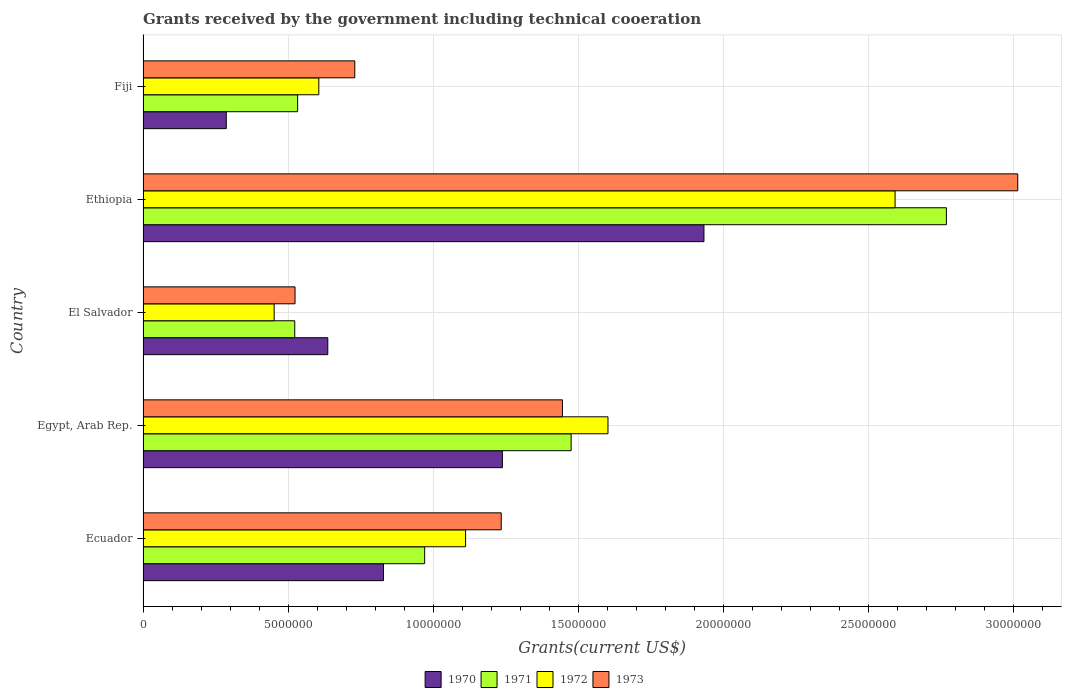How many different coloured bars are there?
Your answer should be compact. 4. Are the number of bars on each tick of the Y-axis equal?
Offer a terse response. Yes. How many bars are there on the 4th tick from the top?
Offer a very short reply. 4. How many bars are there on the 5th tick from the bottom?
Make the answer very short. 4. What is the label of the 3rd group of bars from the top?
Offer a very short reply. El Salvador. What is the total grants received by the government in 1973 in Ecuador?
Your answer should be compact. 1.24e+07. Across all countries, what is the maximum total grants received by the government in 1973?
Provide a short and direct response. 3.02e+07. Across all countries, what is the minimum total grants received by the government in 1970?
Provide a short and direct response. 2.87e+06. In which country was the total grants received by the government in 1972 maximum?
Your answer should be compact. Ethiopia. In which country was the total grants received by the government in 1973 minimum?
Offer a very short reply. El Salvador. What is the total total grants received by the government in 1971 in the graph?
Provide a short and direct response. 6.27e+07. What is the difference between the total grants received by the government in 1972 in Ecuador and that in Egypt, Arab Rep.?
Make the answer very short. -4.91e+06. What is the difference between the total grants received by the government in 1970 in Ecuador and the total grants received by the government in 1973 in El Salvador?
Your answer should be very brief. 3.05e+06. What is the average total grants received by the government in 1972 per country?
Provide a short and direct response. 1.27e+07. What is the difference between the total grants received by the government in 1971 and total grants received by the government in 1970 in Egypt, Arab Rep.?
Ensure brevity in your answer.  2.37e+06. In how many countries, is the total grants received by the government in 1973 greater than 5000000 US$?
Give a very brief answer. 5. What is the ratio of the total grants received by the government in 1971 in Egypt, Arab Rep. to that in Fiji?
Ensure brevity in your answer.  2.77. What is the difference between the highest and the second highest total grants received by the government in 1973?
Ensure brevity in your answer.  1.57e+07. What is the difference between the highest and the lowest total grants received by the government in 1970?
Provide a short and direct response. 1.65e+07. In how many countries, is the total grants received by the government in 1973 greater than the average total grants received by the government in 1973 taken over all countries?
Make the answer very short. 2. Is it the case that in every country, the sum of the total grants received by the government in 1972 and total grants received by the government in 1973 is greater than the sum of total grants received by the government in 1970 and total grants received by the government in 1971?
Make the answer very short. No. Is it the case that in every country, the sum of the total grants received by the government in 1970 and total grants received by the government in 1972 is greater than the total grants received by the government in 1971?
Offer a terse response. Yes. How many bars are there?
Offer a very short reply. 20. How many countries are there in the graph?
Your response must be concise. 5. What is the difference between two consecutive major ticks on the X-axis?
Keep it short and to the point. 5.00e+06. Where does the legend appear in the graph?
Offer a very short reply. Bottom center. How are the legend labels stacked?
Your answer should be compact. Horizontal. What is the title of the graph?
Give a very brief answer. Grants received by the government including technical cooeration. Does "2008" appear as one of the legend labels in the graph?
Offer a terse response. No. What is the label or title of the X-axis?
Ensure brevity in your answer.  Grants(current US$). What is the Grants(current US$) in 1970 in Ecuador?
Offer a terse response. 8.29e+06. What is the Grants(current US$) in 1971 in Ecuador?
Keep it short and to the point. 9.71e+06. What is the Grants(current US$) in 1972 in Ecuador?
Offer a very short reply. 1.11e+07. What is the Grants(current US$) in 1973 in Ecuador?
Make the answer very short. 1.24e+07. What is the Grants(current US$) in 1970 in Egypt, Arab Rep.?
Keep it short and to the point. 1.24e+07. What is the Grants(current US$) of 1971 in Egypt, Arab Rep.?
Ensure brevity in your answer.  1.48e+07. What is the Grants(current US$) in 1972 in Egypt, Arab Rep.?
Provide a succinct answer. 1.60e+07. What is the Grants(current US$) in 1973 in Egypt, Arab Rep.?
Your answer should be very brief. 1.45e+07. What is the Grants(current US$) in 1970 in El Salvador?
Your answer should be very brief. 6.37e+06. What is the Grants(current US$) of 1971 in El Salvador?
Keep it short and to the point. 5.23e+06. What is the Grants(current US$) in 1972 in El Salvador?
Ensure brevity in your answer.  4.52e+06. What is the Grants(current US$) of 1973 in El Salvador?
Offer a very short reply. 5.24e+06. What is the Grants(current US$) of 1970 in Ethiopia?
Your answer should be compact. 1.93e+07. What is the Grants(current US$) in 1971 in Ethiopia?
Provide a succinct answer. 2.77e+07. What is the Grants(current US$) in 1972 in Ethiopia?
Keep it short and to the point. 2.59e+07. What is the Grants(current US$) of 1973 in Ethiopia?
Ensure brevity in your answer.  3.02e+07. What is the Grants(current US$) in 1970 in Fiji?
Offer a very short reply. 2.87e+06. What is the Grants(current US$) of 1971 in Fiji?
Offer a terse response. 5.33e+06. What is the Grants(current US$) in 1972 in Fiji?
Your response must be concise. 6.06e+06. What is the Grants(current US$) of 1973 in Fiji?
Provide a succinct answer. 7.30e+06. Across all countries, what is the maximum Grants(current US$) of 1970?
Ensure brevity in your answer.  1.93e+07. Across all countries, what is the maximum Grants(current US$) of 1971?
Offer a very short reply. 2.77e+07. Across all countries, what is the maximum Grants(current US$) in 1972?
Ensure brevity in your answer.  2.59e+07. Across all countries, what is the maximum Grants(current US$) in 1973?
Offer a terse response. 3.02e+07. Across all countries, what is the minimum Grants(current US$) of 1970?
Your answer should be compact. 2.87e+06. Across all countries, what is the minimum Grants(current US$) in 1971?
Provide a succinct answer. 5.23e+06. Across all countries, what is the minimum Grants(current US$) of 1972?
Your response must be concise. 4.52e+06. Across all countries, what is the minimum Grants(current US$) in 1973?
Ensure brevity in your answer.  5.24e+06. What is the total Grants(current US$) in 1970 in the graph?
Keep it short and to the point. 4.93e+07. What is the total Grants(current US$) of 1971 in the graph?
Your answer should be compact. 6.27e+07. What is the total Grants(current US$) of 1972 in the graph?
Offer a terse response. 6.37e+07. What is the total Grants(current US$) of 1973 in the graph?
Your answer should be very brief. 6.95e+07. What is the difference between the Grants(current US$) of 1970 in Ecuador and that in Egypt, Arab Rep.?
Make the answer very short. -4.10e+06. What is the difference between the Grants(current US$) in 1971 in Ecuador and that in Egypt, Arab Rep.?
Offer a terse response. -5.05e+06. What is the difference between the Grants(current US$) in 1972 in Ecuador and that in Egypt, Arab Rep.?
Provide a short and direct response. -4.91e+06. What is the difference between the Grants(current US$) in 1973 in Ecuador and that in Egypt, Arab Rep.?
Give a very brief answer. -2.11e+06. What is the difference between the Grants(current US$) of 1970 in Ecuador and that in El Salvador?
Provide a succinct answer. 1.92e+06. What is the difference between the Grants(current US$) in 1971 in Ecuador and that in El Salvador?
Your response must be concise. 4.48e+06. What is the difference between the Grants(current US$) in 1972 in Ecuador and that in El Salvador?
Your response must be concise. 6.60e+06. What is the difference between the Grants(current US$) in 1973 in Ecuador and that in El Salvador?
Offer a terse response. 7.11e+06. What is the difference between the Grants(current US$) of 1970 in Ecuador and that in Ethiopia?
Your response must be concise. -1.10e+07. What is the difference between the Grants(current US$) of 1971 in Ecuador and that in Ethiopia?
Provide a short and direct response. -1.80e+07. What is the difference between the Grants(current US$) in 1972 in Ecuador and that in Ethiopia?
Your answer should be compact. -1.48e+07. What is the difference between the Grants(current US$) in 1973 in Ecuador and that in Ethiopia?
Provide a short and direct response. -1.78e+07. What is the difference between the Grants(current US$) in 1970 in Ecuador and that in Fiji?
Provide a succinct answer. 5.42e+06. What is the difference between the Grants(current US$) of 1971 in Ecuador and that in Fiji?
Your response must be concise. 4.38e+06. What is the difference between the Grants(current US$) of 1972 in Ecuador and that in Fiji?
Keep it short and to the point. 5.06e+06. What is the difference between the Grants(current US$) of 1973 in Ecuador and that in Fiji?
Make the answer very short. 5.05e+06. What is the difference between the Grants(current US$) of 1970 in Egypt, Arab Rep. and that in El Salvador?
Give a very brief answer. 6.02e+06. What is the difference between the Grants(current US$) in 1971 in Egypt, Arab Rep. and that in El Salvador?
Give a very brief answer. 9.53e+06. What is the difference between the Grants(current US$) in 1972 in Egypt, Arab Rep. and that in El Salvador?
Your answer should be very brief. 1.15e+07. What is the difference between the Grants(current US$) of 1973 in Egypt, Arab Rep. and that in El Salvador?
Your answer should be compact. 9.22e+06. What is the difference between the Grants(current US$) of 1970 in Egypt, Arab Rep. and that in Ethiopia?
Provide a succinct answer. -6.95e+06. What is the difference between the Grants(current US$) of 1971 in Egypt, Arab Rep. and that in Ethiopia?
Offer a very short reply. -1.29e+07. What is the difference between the Grants(current US$) of 1972 in Egypt, Arab Rep. and that in Ethiopia?
Make the answer very short. -9.90e+06. What is the difference between the Grants(current US$) in 1973 in Egypt, Arab Rep. and that in Ethiopia?
Your answer should be very brief. -1.57e+07. What is the difference between the Grants(current US$) in 1970 in Egypt, Arab Rep. and that in Fiji?
Keep it short and to the point. 9.52e+06. What is the difference between the Grants(current US$) of 1971 in Egypt, Arab Rep. and that in Fiji?
Make the answer very short. 9.43e+06. What is the difference between the Grants(current US$) of 1972 in Egypt, Arab Rep. and that in Fiji?
Your answer should be very brief. 9.97e+06. What is the difference between the Grants(current US$) of 1973 in Egypt, Arab Rep. and that in Fiji?
Your answer should be compact. 7.16e+06. What is the difference between the Grants(current US$) of 1970 in El Salvador and that in Ethiopia?
Make the answer very short. -1.30e+07. What is the difference between the Grants(current US$) in 1971 in El Salvador and that in Ethiopia?
Make the answer very short. -2.25e+07. What is the difference between the Grants(current US$) of 1972 in El Salvador and that in Ethiopia?
Give a very brief answer. -2.14e+07. What is the difference between the Grants(current US$) in 1973 in El Salvador and that in Ethiopia?
Ensure brevity in your answer.  -2.49e+07. What is the difference between the Grants(current US$) of 1970 in El Salvador and that in Fiji?
Offer a very short reply. 3.50e+06. What is the difference between the Grants(current US$) of 1972 in El Salvador and that in Fiji?
Make the answer very short. -1.54e+06. What is the difference between the Grants(current US$) in 1973 in El Salvador and that in Fiji?
Ensure brevity in your answer.  -2.06e+06. What is the difference between the Grants(current US$) in 1970 in Ethiopia and that in Fiji?
Offer a terse response. 1.65e+07. What is the difference between the Grants(current US$) of 1971 in Ethiopia and that in Fiji?
Your response must be concise. 2.24e+07. What is the difference between the Grants(current US$) of 1972 in Ethiopia and that in Fiji?
Your answer should be compact. 1.99e+07. What is the difference between the Grants(current US$) of 1973 in Ethiopia and that in Fiji?
Ensure brevity in your answer.  2.29e+07. What is the difference between the Grants(current US$) of 1970 in Ecuador and the Grants(current US$) of 1971 in Egypt, Arab Rep.?
Give a very brief answer. -6.47e+06. What is the difference between the Grants(current US$) in 1970 in Ecuador and the Grants(current US$) in 1972 in Egypt, Arab Rep.?
Ensure brevity in your answer.  -7.74e+06. What is the difference between the Grants(current US$) in 1970 in Ecuador and the Grants(current US$) in 1973 in Egypt, Arab Rep.?
Make the answer very short. -6.17e+06. What is the difference between the Grants(current US$) of 1971 in Ecuador and the Grants(current US$) of 1972 in Egypt, Arab Rep.?
Keep it short and to the point. -6.32e+06. What is the difference between the Grants(current US$) of 1971 in Ecuador and the Grants(current US$) of 1973 in Egypt, Arab Rep.?
Give a very brief answer. -4.75e+06. What is the difference between the Grants(current US$) in 1972 in Ecuador and the Grants(current US$) in 1973 in Egypt, Arab Rep.?
Provide a short and direct response. -3.34e+06. What is the difference between the Grants(current US$) of 1970 in Ecuador and the Grants(current US$) of 1971 in El Salvador?
Provide a succinct answer. 3.06e+06. What is the difference between the Grants(current US$) in 1970 in Ecuador and the Grants(current US$) in 1972 in El Salvador?
Provide a succinct answer. 3.77e+06. What is the difference between the Grants(current US$) of 1970 in Ecuador and the Grants(current US$) of 1973 in El Salvador?
Your answer should be very brief. 3.05e+06. What is the difference between the Grants(current US$) of 1971 in Ecuador and the Grants(current US$) of 1972 in El Salvador?
Offer a very short reply. 5.19e+06. What is the difference between the Grants(current US$) of 1971 in Ecuador and the Grants(current US$) of 1973 in El Salvador?
Provide a succinct answer. 4.47e+06. What is the difference between the Grants(current US$) of 1972 in Ecuador and the Grants(current US$) of 1973 in El Salvador?
Provide a short and direct response. 5.88e+06. What is the difference between the Grants(current US$) of 1970 in Ecuador and the Grants(current US$) of 1971 in Ethiopia?
Provide a short and direct response. -1.94e+07. What is the difference between the Grants(current US$) of 1970 in Ecuador and the Grants(current US$) of 1972 in Ethiopia?
Your response must be concise. -1.76e+07. What is the difference between the Grants(current US$) in 1970 in Ecuador and the Grants(current US$) in 1973 in Ethiopia?
Your answer should be very brief. -2.19e+07. What is the difference between the Grants(current US$) in 1971 in Ecuador and the Grants(current US$) in 1972 in Ethiopia?
Make the answer very short. -1.62e+07. What is the difference between the Grants(current US$) in 1971 in Ecuador and the Grants(current US$) in 1973 in Ethiopia?
Ensure brevity in your answer.  -2.04e+07. What is the difference between the Grants(current US$) in 1972 in Ecuador and the Grants(current US$) in 1973 in Ethiopia?
Give a very brief answer. -1.90e+07. What is the difference between the Grants(current US$) in 1970 in Ecuador and the Grants(current US$) in 1971 in Fiji?
Ensure brevity in your answer.  2.96e+06. What is the difference between the Grants(current US$) in 1970 in Ecuador and the Grants(current US$) in 1972 in Fiji?
Ensure brevity in your answer.  2.23e+06. What is the difference between the Grants(current US$) of 1970 in Ecuador and the Grants(current US$) of 1973 in Fiji?
Offer a very short reply. 9.90e+05. What is the difference between the Grants(current US$) in 1971 in Ecuador and the Grants(current US$) in 1972 in Fiji?
Your answer should be very brief. 3.65e+06. What is the difference between the Grants(current US$) in 1971 in Ecuador and the Grants(current US$) in 1973 in Fiji?
Provide a succinct answer. 2.41e+06. What is the difference between the Grants(current US$) of 1972 in Ecuador and the Grants(current US$) of 1973 in Fiji?
Offer a terse response. 3.82e+06. What is the difference between the Grants(current US$) of 1970 in Egypt, Arab Rep. and the Grants(current US$) of 1971 in El Salvador?
Ensure brevity in your answer.  7.16e+06. What is the difference between the Grants(current US$) of 1970 in Egypt, Arab Rep. and the Grants(current US$) of 1972 in El Salvador?
Offer a very short reply. 7.87e+06. What is the difference between the Grants(current US$) of 1970 in Egypt, Arab Rep. and the Grants(current US$) of 1973 in El Salvador?
Offer a very short reply. 7.15e+06. What is the difference between the Grants(current US$) of 1971 in Egypt, Arab Rep. and the Grants(current US$) of 1972 in El Salvador?
Ensure brevity in your answer.  1.02e+07. What is the difference between the Grants(current US$) of 1971 in Egypt, Arab Rep. and the Grants(current US$) of 1973 in El Salvador?
Provide a succinct answer. 9.52e+06. What is the difference between the Grants(current US$) of 1972 in Egypt, Arab Rep. and the Grants(current US$) of 1973 in El Salvador?
Offer a terse response. 1.08e+07. What is the difference between the Grants(current US$) in 1970 in Egypt, Arab Rep. and the Grants(current US$) in 1971 in Ethiopia?
Your answer should be compact. -1.53e+07. What is the difference between the Grants(current US$) of 1970 in Egypt, Arab Rep. and the Grants(current US$) of 1972 in Ethiopia?
Your response must be concise. -1.35e+07. What is the difference between the Grants(current US$) in 1970 in Egypt, Arab Rep. and the Grants(current US$) in 1973 in Ethiopia?
Give a very brief answer. -1.78e+07. What is the difference between the Grants(current US$) in 1971 in Egypt, Arab Rep. and the Grants(current US$) in 1972 in Ethiopia?
Offer a very short reply. -1.12e+07. What is the difference between the Grants(current US$) of 1971 in Egypt, Arab Rep. and the Grants(current US$) of 1973 in Ethiopia?
Ensure brevity in your answer.  -1.54e+07. What is the difference between the Grants(current US$) of 1972 in Egypt, Arab Rep. and the Grants(current US$) of 1973 in Ethiopia?
Make the answer very short. -1.41e+07. What is the difference between the Grants(current US$) of 1970 in Egypt, Arab Rep. and the Grants(current US$) of 1971 in Fiji?
Ensure brevity in your answer.  7.06e+06. What is the difference between the Grants(current US$) in 1970 in Egypt, Arab Rep. and the Grants(current US$) in 1972 in Fiji?
Make the answer very short. 6.33e+06. What is the difference between the Grants(current US$) in 1970 in Egypt, Arab Rep. and the Grants(current US$) in 1973 in Fiji?
Offer a terse response. 5.09e+06. What is the difference between the Grants(current US$) in 1971 in Egypt, Arab Rep. and the Grants(current US$) in 1972 in Fiji?
Your answer should be very brief. 8.70e+06. What is the difference between the Grants(current US$) in 1971 in Egypt, Arab Rep. and the Grants(current US$) in 1973 in Fiji?
Provide a succinct answer. 7.46e+06. What is the difference between the Grants(current US$) in 1972 in Egypt, Arab Rep. and the Grants(current US$) in 1973 in Fiji?
Offer a very short reply. 8.73e+06. What is the difference between the Grants(current US$) of 1970 in El Salvador and the Grants(current US$) of 1971 in Ethiopia?
Ensure brevity in your answer.  -2.13e+07. What is the difference between the Grants(current US$) of 1970 in El Salvador and the Grants(current US$) of 1972 in Ethiopia?
Provide a succinct answer. -1.96e+07. What is the difference between the Grants(current US$) of 1970 in El Salvador and the Grants(current US$) of 1973 in Ethiopia?
Your answer should be very brief. -2.38e+07. What is the difference between the Grants(current US$) of 1971 in El Salvador and the Grants(current US$) of 1972 in Ethiopia?
Your response must be concise. -2.07e+07. What is the difference between the Grants(current US$) of 1971 in El Salvador and the Grants(current US$) of 1973 in Ethiopia?
Offer a terse response. -2.49e+07. What is the difference between the Grants(current US$) of 1972 in El Salvador and the Grants(current US$) of 1973 in Ethiopia?
Keep it short and to the point. -2.56e+07. What is the difference between the Grants(current US$) of 1970 in El Salvador and the Grants(current US$) of 1971 in Fiji?
Keep it short and to the point. 1.04e+06. What is the difference between the Grants(current US$) of 1970 in El Salvador and the Grants(current US$) of 1972 in Fiji?
Your answer should be very brief. 3.10e+05. What is the difference between the Grants(current US$) of 1970 in El Salvador and the Grants(current US$) of 1973 in Fiji?
Give a very brief answer. -9.30e+05. What is the difference between the Grants(current US$) in 1971 in El Salvador and the Grants(current US$) in 1972 in Fiji?
Your answer should be compact. -8.30e+05. What is the difference between the Grants(current US$) in 1971 in El Salvador and the Grants(current US$) in 1973 in Fiji?
Provide a short and direct response. -2.07e+06. What is the difference between the Grants(current US$) of 1972 in El Salvador and the Grants(current US$) of 1973 in Fiji?
Ensure brevity in your answer.  -2.78e+06. What is the difference between the Grants(current US$) in 1970 in Ethiopia and the Grants(current US$) in 1971 in Fiji?
Give a very brief answer. 1.40e+07. What is the difference between the Grants(current US$) of 1970 in Ethiopia and the Grants(current US$) of 1972 in Fiji?
Provide a short and direct response. 1.33e+07. What is the difference between the Grants(current US$) of 1970 in Ethiopia and the Grants(current US$) of 1973 in Fiji?
Ensure brevity in your answer.  1.20e+07. What is the difference between the Grants(current US$) of 1971 in Ethiopia and the Grants(current US$) of 1972 in Fiji?
Your answer should be compact. 2.16e+07. What is the difference between the Grants(current US$) of 1971 in Ethiopia and the Grants(current US$) of 1973 in Fiji?
Your answer should be compact. 2.04e+07. What is the difference between the Grants(current US$) of 1972 in Ethiopia and the Grants(current US$) of 1973 in Fiji?
Keep it short and to the point. 1.86e+07. What is the average Grants(current US$) in 1970 per country?
Provide a short and direct response. 9.85e+06. What is the average Grants(current US$) in 1971 per country?
Ensure brevity in your answer.  1.25e+07. What is the average Grants(current US$) in 1972 per country?
Ensure brevity in your answer.  1.27e+07. What is the average Grants(current US$) in 1973 per country?
Your answer should be very brief. 1.39e+07. What is the difference between the Grants(current US$) of 1970 and Grants(current US$) of 1971 in Ecuador?
Your response must be concise. -1.42e+06. What is the difference between the Grants(current US$) of 1970 and Grants(current US$) of 1972 in Ecuador?
Provide a short and direct response. -2.83e+06. What is the difference between the Grants(current US$) in 1970 and Grants(current US$) in 1973 in Ecuador?
Make the answer very short. -4.06e+06. What is the difference between the Grants(current US$) of 1971 and Grants(current US$) of 1972 in Ecuador?
Your answer should be compact. -1.41e+06. What is the difference between the Grants(current US$) of 1971 and Grants(current US$) of 1973 in Ecuador?
Your response must be concise. -2.64e+06. What is the difference between the Grants(current US$) in 1972 and Grants(current US$) in 1973 in Ecuador?
Provide a short and direct response. -1.23e+06. What is the difference between the Grants(current US$) in 1970 and Grants(current US$) in 1971 in Egypt, Arab Rep.?
Provide a succinct answer. -2.37e+06. What is the difference between the Grants(current US$) of 1970 and Grants(current US$) of 1972 in Egypt, Arab Rep.?
Your answer should be very brief. -3.64e+06. What is the difference between the Grants(current US$) of 1970 and Grants(current US$) of 1973 in Egypt, Arab Rep.?
Your answer should be very brief. -2.07e+06. What is the difference between the Grants(current US$) in 1971 and Grants(current US$) in 1972 in Egypt, Arab Rep.?
Provide a short and direct response. -1.27e+06. What is the difference between the Grants(current US$) in 1971 and Grants(current US$) in 1973 in Egypt, Arab Rep.?
Your answer should be compact. 3.00e+05. What is the difference between the Grants(current US$) in 1972 and Grants(current US$) in 1973 in Egypt, Arab Rep.?
Your answer should be very brief. 1.57e+06. What is the difference between the Grants(current US$) of 1970 and Grants(current US$) of 1971 in El Salvador?
Ensure brevity in your answer.  1.14e+06. What is the difference between the Grants(current US$) of 1970 and Grants(current US$) of 1972 in El Salvador?
Your answer should be compact. 1.85e+06. What is the difference between the Grants(current US$) in 1970 and Grants(current US$) in 1973 in El Salvador?
Offer a very short reply. 1.13e+06. What is the difference between the Grants(current US$) in 1971 and Grants(current US$) in 1972 in El Salvador?
Offer a terse response. 7.10e+05. What is the difference between the Grants(current US$) of 1972 and Grants(current US$) of 1973 in El Salvador?
Offer a very short reply. -7.20e+05. What is the difference between the Grants(current US$) of 1970 and Grants(current US$) of 1971 in Ethiopia?
Offer a very short reply. -8.36e+06. What is the difference between the Grants(current US$) of 1970 and Grants(current US$) of 1972 in Ethiopia?
Your answer should be very brief. -6.59e+06. What is the difference between the Grants(current US$) of 1970 and Grants(current US$) of 1973 in Ethiopia?
Your answer should be very brief. -1.08e+07. What is the difference between the Grants(current US$) in 1971 and Grants(current US$) in 1972 in Ethiopia?
Offer a terse response. 1.77e+06. What is the difference between the Grants(current US$) in 1971 and Grants(current US$) in 1973 in Ethiopia?
Ensure brevity in your answer.  -2.46e+06. What is the difference between the Grants(current US$) in 1972 and Grants(current US$) in 1973 in Ethiopia?
Make the answer very short. -4.23e+06. What is the difference between the Grants(current US$) in 1970 and Grants(current US$) in 1971 in Fiji?
Give a very brief answer. -2.46e+06. What is the difference between the Grants(current US$) in 1970 and Grants(current US$) in 1972 in Fiji?
Your response must be concise. -3.19e+06. What is the difference between the Grants(current US$) of 1970 and Grants(current US$) of 1973 in Fiji?
Your answer should be very brief. -4.43e+06. What is the difference between the Grants(current US$) of 1971 and Grants(current US$) of 1972 in Fiji?
Your response must be concise. -7.30e+05. What is the difference between the Grants(current US$) in 1971 and Grants(current US$) in 1973 in Fiji?
Provide a succinct answer. -1.97e+06. What is the difference between the Grants(current US$) in 1972 and Grants(current US$) in 1973 in Fiji?
Give a very brief answer. -1.24e+06. What is the ratio of the Grants(current US$) of 1970 in Ecuador to that in Egypt, Arab Rep.?
Make the answer very short. 0.67. What is the ratio of the Grants(current US$) in 1971 in Ecuador to that in Egypt, Arab Rep.?
Offer a terse response. 0.66. What is the ratio of the Grants(current US$) in 1972 in Ecuador to that in Egypt, Arab Rep.?
Ensure brevity in your answer.  0.69. What is the ratio of the Grants(current US$) of 1973 in Ecuador to that in Egypt, Arab Rep.?
Give a very brief answer. 0.85. What is the ratio of the Grants(current US$) in 1970 in Ecuador to that in El Salvador?
Your answer should be very brief. 1.3. What is the ratio of the Grants(current US$) of 1971 in Ecuador to that in El Salvador?
Offer a terse response. 1.86. What is the ratio of the Grants(current US$) in 1972 in Ecuador to that in El Salvador?
Make the answer very short. 2.46. What is the ratio of the Grants(current US$) of 1973 in Ecuador to that in El Salvador?
Ensure brevity in your answer.  2.36. What is the ratio of the Grants(current US$) in 1970 in Ecuador to that in Ethiopia?
Offer a very short reply. 0.43. What is the ratio of the Grants(current US$) in 1971 in Ecuador to that in Ethiopia?
Your answer should be compact. 0.35. What is the ratio of the Grants(current US$) of 1972 in Ecuador to that in Ethiopia?
Keep it short and to the point. 0.43. What is the ratio of the Grants(current US$) of 1973 in Ecuador to that in Ethiopia?
Your response must be concise. 0.41. What is the ratio of the Grants(current US$) of 1970 in Ecuador to that in Fiji?
Make the answer very short. 2.89. What is the ratio of the Grants(current US$) in 1971 in Ecuador to that in Fiji?
Offer a terse response. 1.82. What is the ratio of the Grants(current US$) of 1972 in Ecuador to that in Fiji?
Give a very brief answer. 1.83. What is the ratio of the Grants(current US$) in 1973 in Ecuador to that in Fiji?
Offer a terse response. 1.69. What is the ratio of the Grants(current US$) of 1970 in Egypt, Arab Rep. to that in El Salvador?
Your response must be concise. 1.95. What is the ratio of the Grants(current US$) in 1971 in Egypt, Arab Rep. to that in El Salvador?
Keep it short and to the point. 2.82. What is the ratio of the Grants(current US$) in 1972 in Egypt, Arab Rep. to that in El Salvador?
Your response must be concise. 3.55. What is the ratio of the Grants(current US$) of 1973 in Egypt, Arab Rep. to that in El Salvador?
Give a very brief answer. 2.76. What is the ratio of the Grants(current US$) of 1970 in Egypt, Arab Rep. to that in Ethiopia?
Keep it short and to the point. 0.64. What is the ratio of the Grants(current US$) of 1971 in Egypt, Arab Rep. to that in Ethiopia?
Offer a terse response. 0.53. What is the ratio of the Grants(current US$) in 1972 in Egypt, Arab Rep. to that in Ethiopia?
Your answer should be very brief. 0.62. What is the ratio of the Grants(current US$) in 1973 in Egypt, Arab Rep. to that in Ethiopia?
Give a very brief answer. 0.48. What is the ratio of the Grants(current US$) in 1970 in Egypt, Arab Rep. to that in Fiji?
Ensure brevity in your answer.  4.32. What is the ratio of the Grants(current US$) in 1971 in Egypt, Arab Rep. to that in Fiji?
Keep it short and to the point. 2.77. What is the ratio of the Grants(current US$) of 1972 in Egypt, Arab Rep. to that in Fiji?
Ensure brevity in your answer.  2.65. What is the ratio of the Grants(current US$) of 1973 in Egypt, Arab Rep. to that in Fiji?
Your answer should be very brief. 1.98. What is the ratio of the Grants(current US$) in 1970 in El Salvador to that in Ethiopia?
Offer a terse response. 0.33. What is the ratio of the Grants(current US$) of 1971 in El Salvador to that in Ethiopia?
Provide a succinct answer. 0.19. What is the ratio of the Grants(current US$) of 1972 in El Salvador to that in Ethiopia?
Ensure brevity in your answer.  0.17. What is the ratio of the Grants(current US$) in 1973 in El Salvador to that in Ethiopia?
Provide a short and direct response. 0.17. What is the ratio of the Grants(current US$) in 1970 in El Salvador to that in Fiji?
Keep it short and to the point. 2.22. What is the ratio of the Grants(current US$) in 1971 in El Salvador to that in Fiji?
Provide a succinct answer. 0.98. What is the ratio of the Grants(current US$) in 1972 in El Salvador to that in Fiji?
Offer a very short reply. 0.75. What is the ratio of the Grants(current US$) of 1973 in El Salvador to that in Fiji?
Offer a terse response. 0.72. What is the ratio of the Grants(current US$) in 1970 in Ethiopia to that in Fiji?
Offer a terse response. 6.74. What is the ratio of the Grants(current US$) of 1971 in Ethiopia to that in Fiji?
Keep it short and to the point. 5.2. What is the ratio of the Grants(current US$) in 1972 in Ethiopia to that in Fiji?
Keep it short and to the point. 4.28. What is the ratio of the Grants(current US$) of 1973 in Ethiopia to that in Fiji?
Give a very brief answer. 4.13. What is the difference between the highest and the second highest Grants(current US$) of 1970?
Your answer should be compact. 6.95e+06. What is the difference between the highest and the second highest Grants(current US$) in 1971?
Give a very brief answer. 1.29e+07. What is the difference between the highest and the second highest Grants(current US$) in 1972?
Ensure brevity in your answer.  9.90e+06. What is the difference between the highest and the second highest Grants(current US$) in 1973?
Your answer should be compact. 1.57e+07. What is the difference between the highest and the lowest Grants(current US$) in 1970?
Provide a succinct answer. 1.65e+07. What is the difference between the highest and the lowest Grants(current US$) in 1971?
Provide a short and direct response. 2.25e+07. What is the difference between the highest and the lowest Grants(current US$) of 1972?
Make the answer very short. 2.14e+07. What is the difference between the highest and the lowest Grants(current US$) in 1973?
Your answer should be compact. 2.49e+07. 